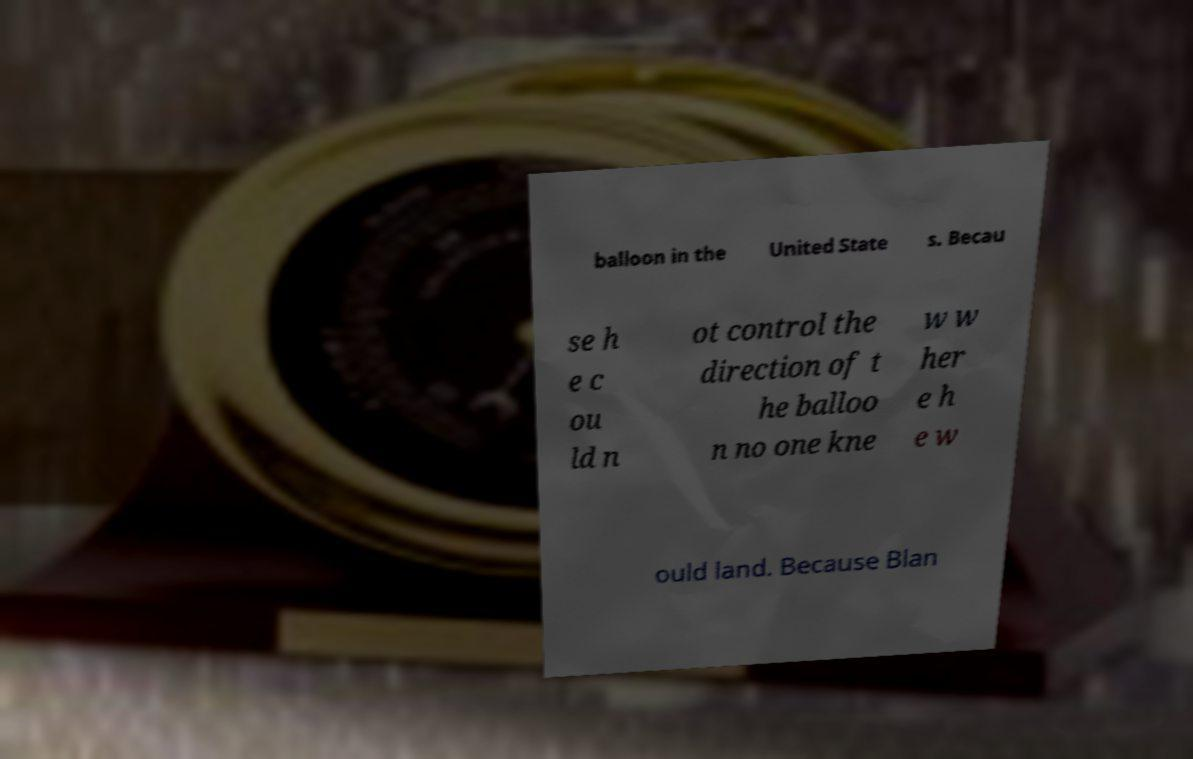Could you extract and type out the text from this image? balloon in the United State s. Becau se h e c ou ld n ot control the direction of t he balloo n no one kne w w her e h e w ould land. Because Blan 